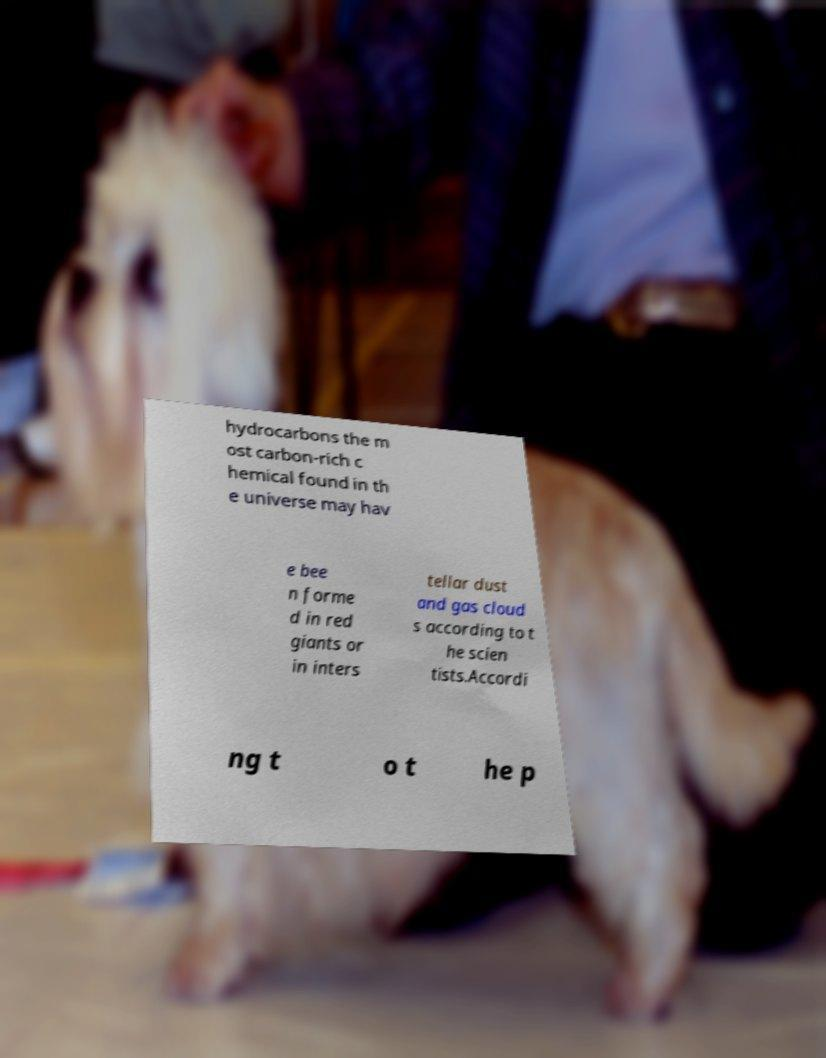I need the written content from this picture converted into text. Can you do that? hydrocarbons the m ost carbon-rich c hemical found in th e universe may hav e bee n forme d in red giants or in inters tellar dust and gas cloud s according to t he scien tists.Accordi ng t o t he p 